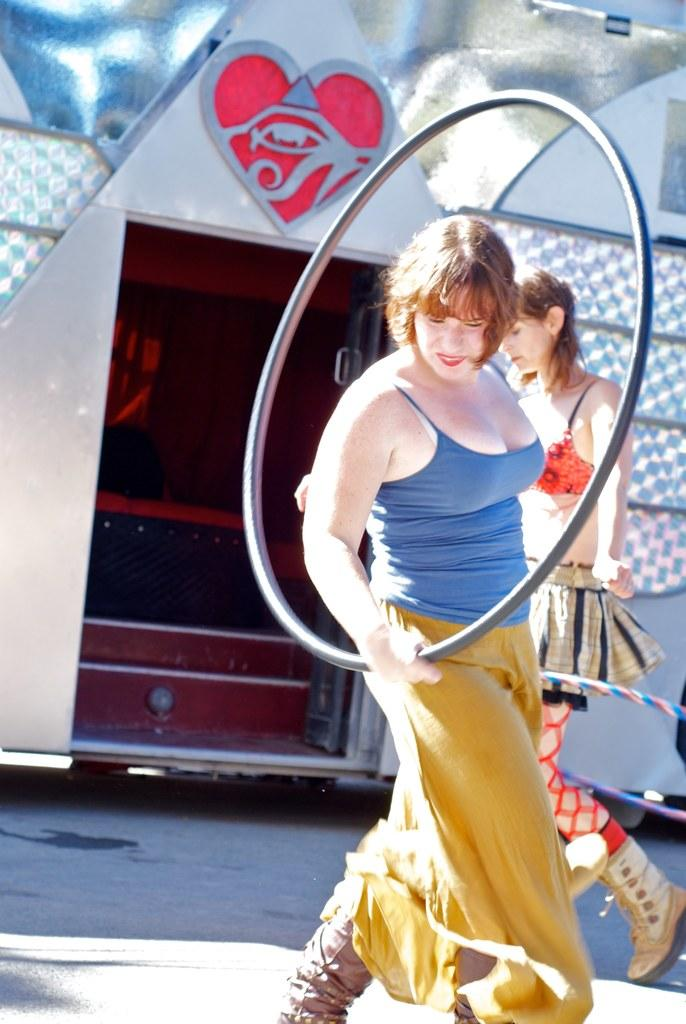How many people are in the image? There are two women in the image. What is one of the women holding? One of the women is holding a circular object. What can be seen in the background of the image? There are stars visible in the background of the image. What type of harmony is being played by the women in the image? There is no indication of any musical instruments or harmonies being played in the image. 